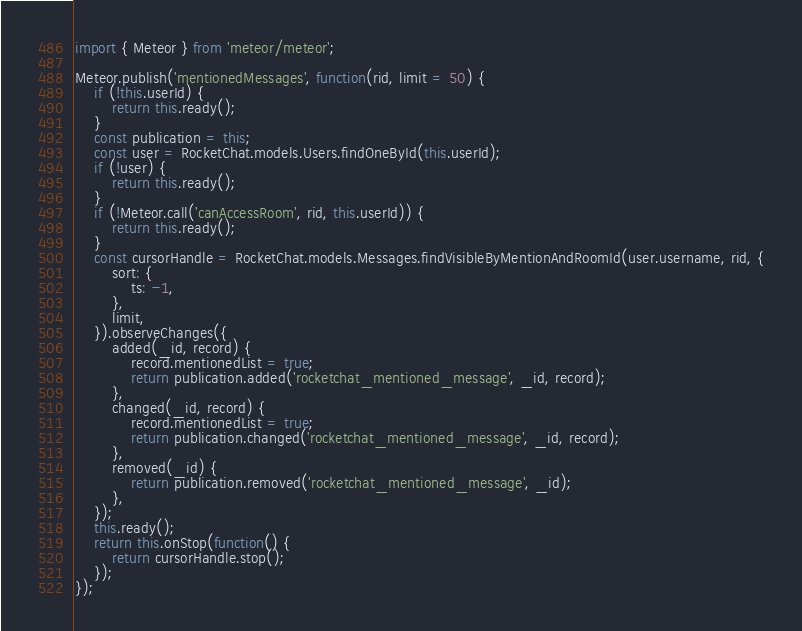<code> <loc_0><loc_0><loc_500><loc_500><_JavaScript_>import { Meteor } from 'meteor/meteor';

Meteor.publish('mentionedMessages', function(rid, limit = 50) {
	if (!this.userId) {
		return this.ready();
	}
	const publication = this;
	const user = RocketChat.models.Users.findOneById(this.userId);
	if (!user) {
		return this.ready();
	}
	if (!Meteor.call('canAccessRoom', rid, this.userId)) {
		return this.ready();
	}
	const cursorHandle = RocketChat.models.Messages.findVisibleByMentionAndRoomId(user.username, rid, {
		sort: {
			ts: -1,
		},
		limit,
	}).observeChanges({
		added(_id, record) {
			record.mentionedList = true;
			return publication.added('rocketchat_mentioned_message', _id, record);
		},
		changed(_id, record) {
			record.mentionedList = true;
			return publication.changed('rocketchat_mentioned_message', _id, record);
		},
		removed(_id) {
			return publication.removed('rocketchat_mentioned_message', _id);
		},
	});
	this.ready();
	return this.onStop(function() {
		return cursorHandle.stop();
	});
});
</code> 